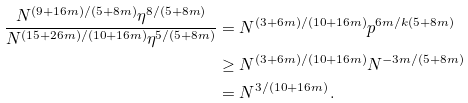<formula> <loc_0><loc_0><loc_500><loc_500>\frac { N ^ { ( 9 + 1 6 m ) / ( 5 + 8 m ) } \eta ^ { 8 / ( 5 + 8 m ) } } { N ^ { ( 1 5 + 2 6 m ) / ( 1 0 + 1 6 m ) } \eta ^ { 5 / ( 5 + 8 m ) } } & = N ^ { ( 3 + 6 m ) / ( 1 0 + 1 6 m ) } p ^ { 6 m / k ( 5 + 8 m ) } \\ & \geq N ^ { ( 3 + 6 m ) / ( 1 0 + 1 6 m ) } N ^ { - 3 m / ( 5 + 8 m ) } \\ & = N ^ { 3 / ( 1 0 + 1 6 m ) } \, .</formula> 